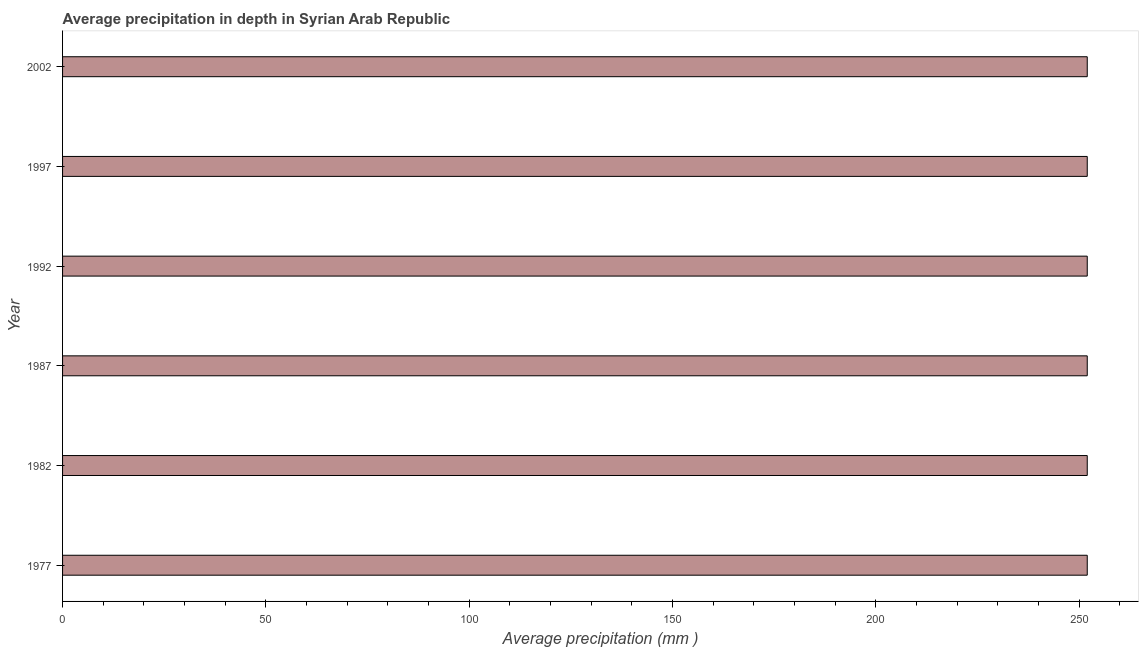Does the graph contain any zero values?
Your answer should be very brief. No. Does the graph contain grids?
Make the answer very short. No. What is the title of the graph?
Keep it short and to the point. Average precipitation in depth in Syrian Arab Republic. What is the label or title of the X-axis?
Your answer should be very brief. Average precipitation (mm ). What is the average precipitation in depth in 1997?
Offer a terse response. 252. Across all years, what is the maximum average precipitation in depth?
Make the answer very short. 252. Across all years, what is the minimum average precipitation in depth?
Offer a very short reply. 252. In which year was the average precipitation in depth minimum?
Your answer should be very brief. 1977. What is the sum of the average precipitation in depth?
Provide a succinct answer. 1512. What is the difference between the average precipitation in depth in 1987 and 1997?
Give a very brief answer. 0. What is the average average precipitation in depth per year?
Keep it short and to the point. 252. What is the median average precipitation in depth?
Provide a short and direct response. 252. Do a majority of the years between 2002 and 1987 (inclusive) have average precipitation in depth greater than 150 mm?
Make the answer very short. Yes. Is the sum of the average precipitation in depth in 1992 and 1997 greater than the maximum average precipitation in depth across all years?
Provide a short and direct response. Yes. In how many years, is the average precipitation in depth greater than the average average precipitation in depth taken over all years?
Your answer should be very brief. 0. Are the values on the major ticks of X-axis written in scientific E-notation?
Give a very brief answer. No. What is the Average precipitation (mm ) of 1977?
Give a very brief answer. 252. What is the Average precipitation (mm ) in 1982?
Your response must be concise. 252. What is the Average precipitation (mm ) of 1987?
Provide a succinct answer. 252. What is the Average precipitation (mm ) in 1992?
Ensure brevity in your answer.  252. What is the Average precipitation (mm ) in 1997?
Give a very brief answer. 252. What is the Average precipitation (mm ) of 2002?
Provide a succinct answer. 252. What is the difference between the Average precipitation (mm ) in 1977 and 1982?
Keep it short and to the point. 0. What is the difference between the Average precipitation (mm ) in 1977 and 1992?
Your answer should be very brief. 0. What is the difference between the Average precipitation (mm ) in 1977 and 1997?
Provide a short and direct response. 0. What is the difference between the Average precipitation (mm ) in 1987 and 1992?
Your answer should be compact. 0. What is the difference between the Average precipitation (mm ) in 1987 and 1997?
Offer a very short reply. 0. What is the difference between the Average precipitation (mm ) in 1992 and 1997?
Provide a succinct answer. 0. What is the ratio of the Average precipitation (mm ) in 1977 to that in 1982?
Your response must be concise. 1. What is the ratio of the Average precipitation (mm ) in 1977 to that in 1992?
Give a very brief answer. 1. What is the ratio of the Average precipitation (mm ) in 1977 to that in 1997?
Offer a very short reply. 1. What is the ratio of the Average precipitation (mm ) in 1982 to that in 1992?
Provide a short and direct response. 1. What is the ratio of the Average precipitation (mm ) in 1987 to that in 1992?
Provide a succinct answer. 1. What is the ratio of the Average precipitation (mm ) in 1987 to that in 1997?
Ensure brevity in your answer.  1. What is the ratio of the Average precipitation (mm ) in 1987 to that in 2002?
Your answer should be compact. 1. What is the ratio of the Average precipitation (mm ) in 1997 to that in 2002?
Ensure brevity in your answer.  1. 